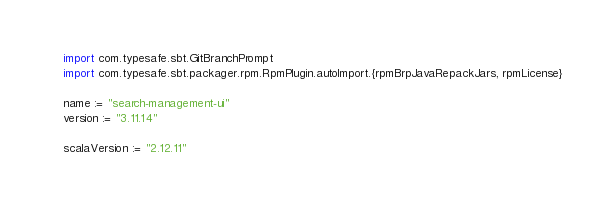<code> <loc_0><loc_0><loc_500><loc_500><_Scala_>import com.typesafe.sbt.GitBranchPrompt
import com.typesafe.sbt.packager.rpm.RpmPlugin.autoImport.{rpmBrpJavaRepackJars, rpmLicense}

name := "search-management-ui"
version := "3.11.14"

scalaVersion := "2.12.11"
</code> 